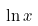<formula> <loc_0><loc_0><loc_500><loc_500>\ln x</formula> 